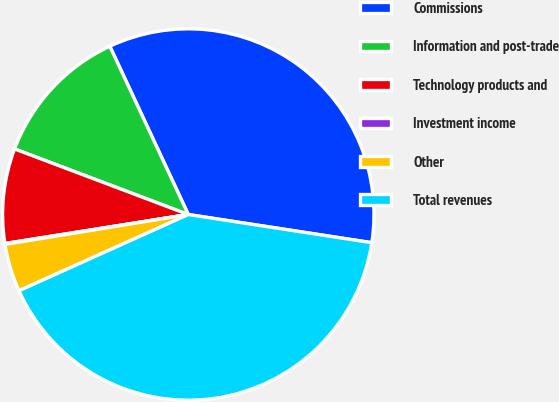Convert chart. <chart><loc_0><loc_0><loc_500><loc_500><pie_chart><fcel>Commissions<fcel>Information and post-trade<fcel>Technology products and<fcel>Investment income<fcel>Other<fcel>Total revenues<nl><fcel>34.37%<fcel>12.31%<fcel>8.24%<fcel>0.08%<fcel>4.16%<fcel>40.84%<nl></chart> 